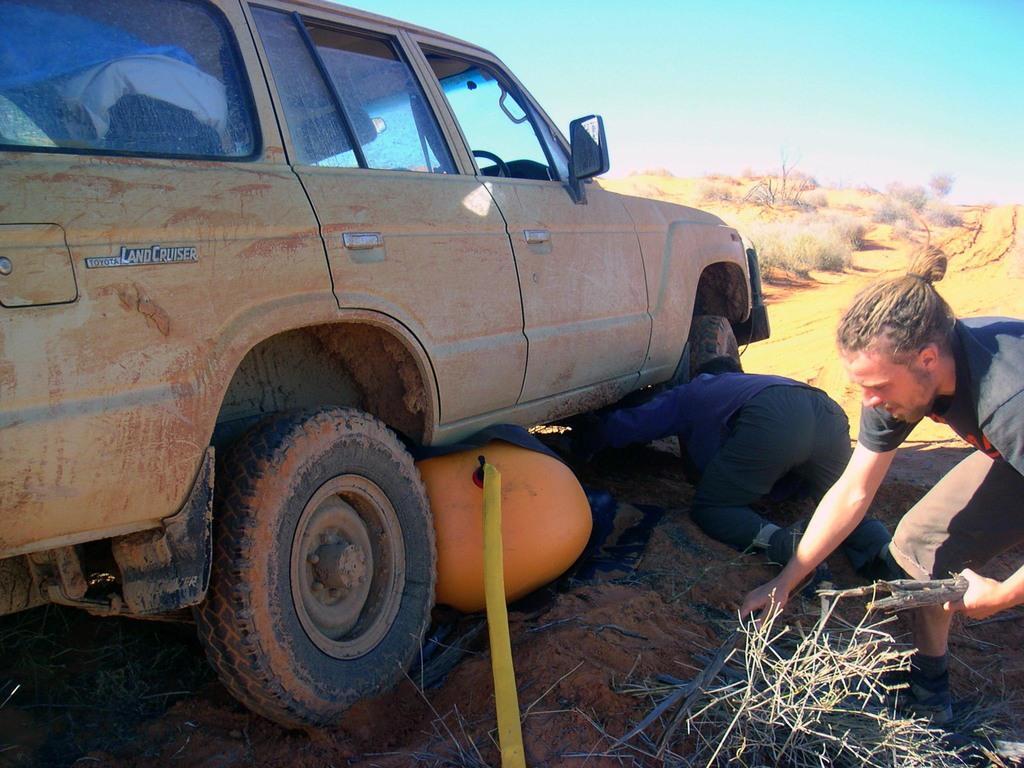Could you give a brief overview of what you see in this image? In the foreground of this is image, there is a car. On right, there is a man holding sticks in his hand and another person going under the car. In the background ,there are plants, path and the sky. 